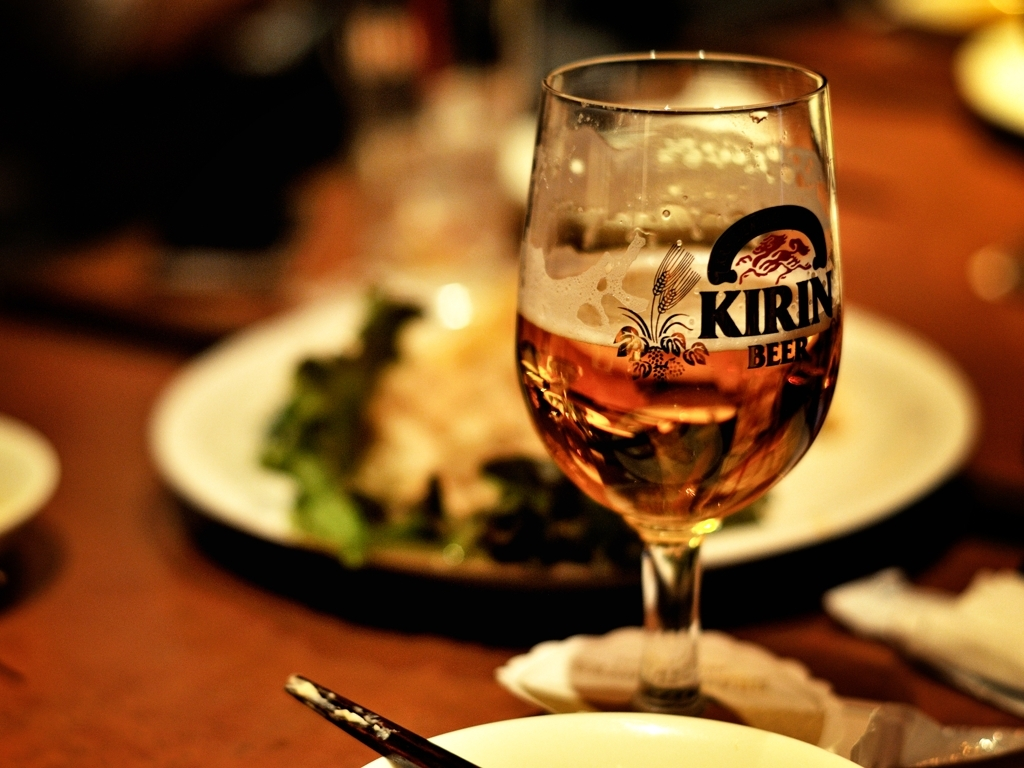Describe the mood or atmosphere you get from this image. The image conveys a cozy and warm atmosphere, possibly a social gathering or a relaxed dining scene. The soft lighting and close-up of the glass give it an inviting, intimate feel. 